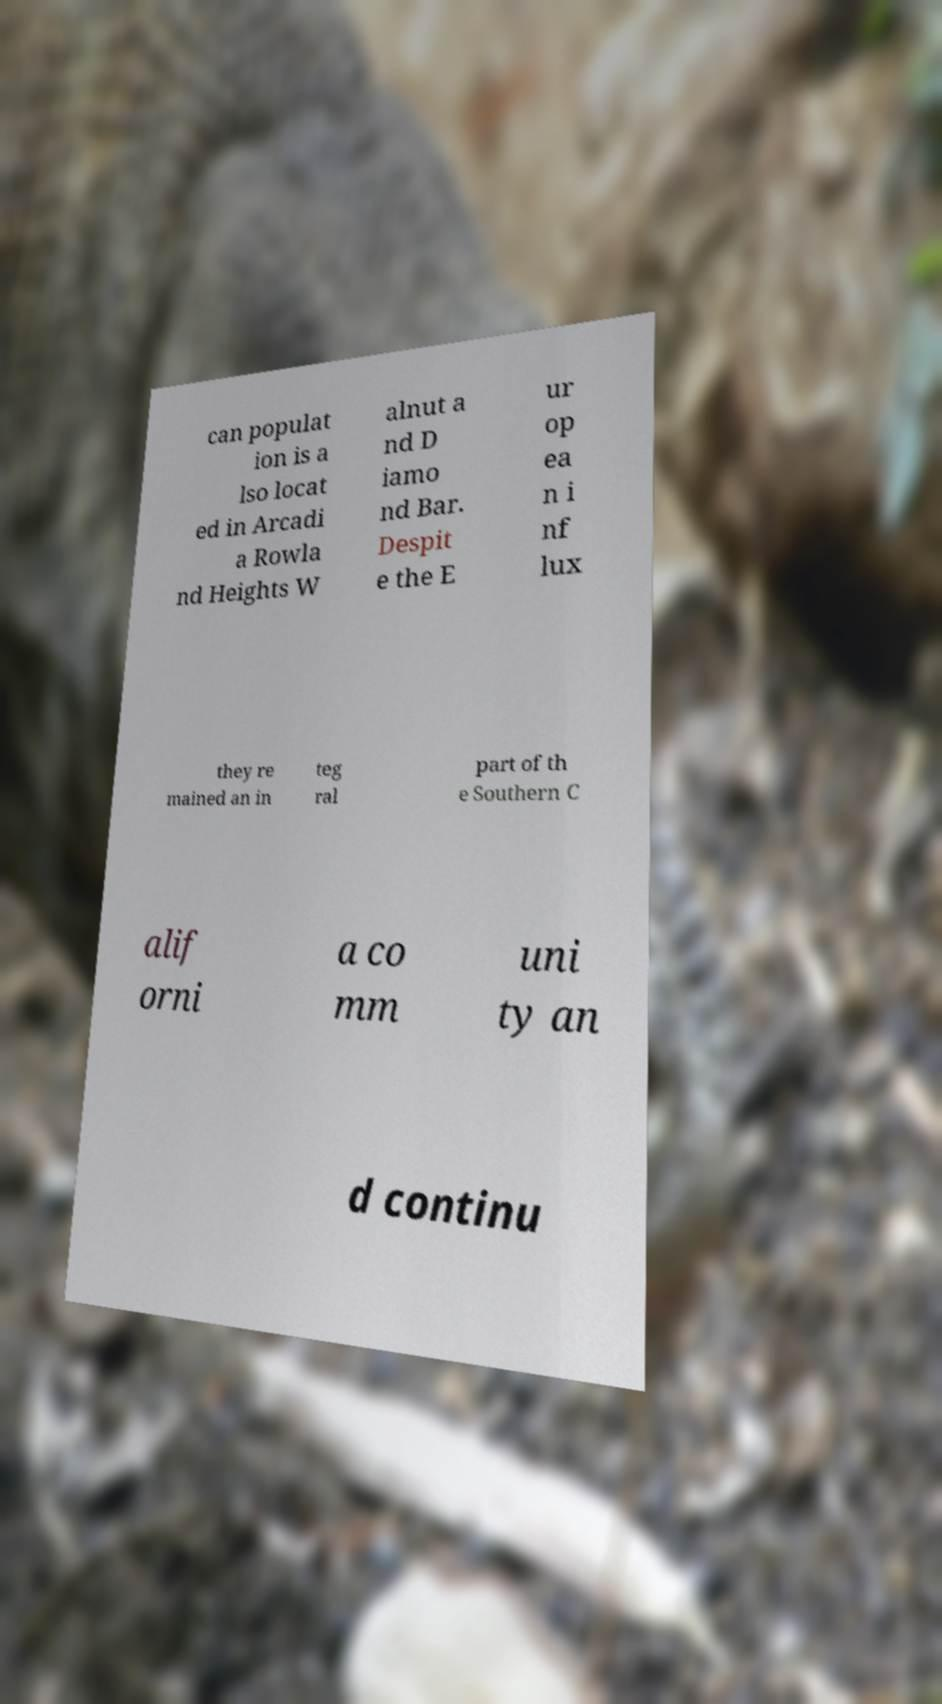For documentation purposes, I need the text within this image transcribed. Could you provide that? can populat ion is a lso locat ed in Arcadi a Rowla nd Heights W alnut a nd D iamo nd Bar. Despit e the E ur op ea n i nf lux they re mained an in teg ral part of th e Southern C alif orni a co mm uni ty an d continu 